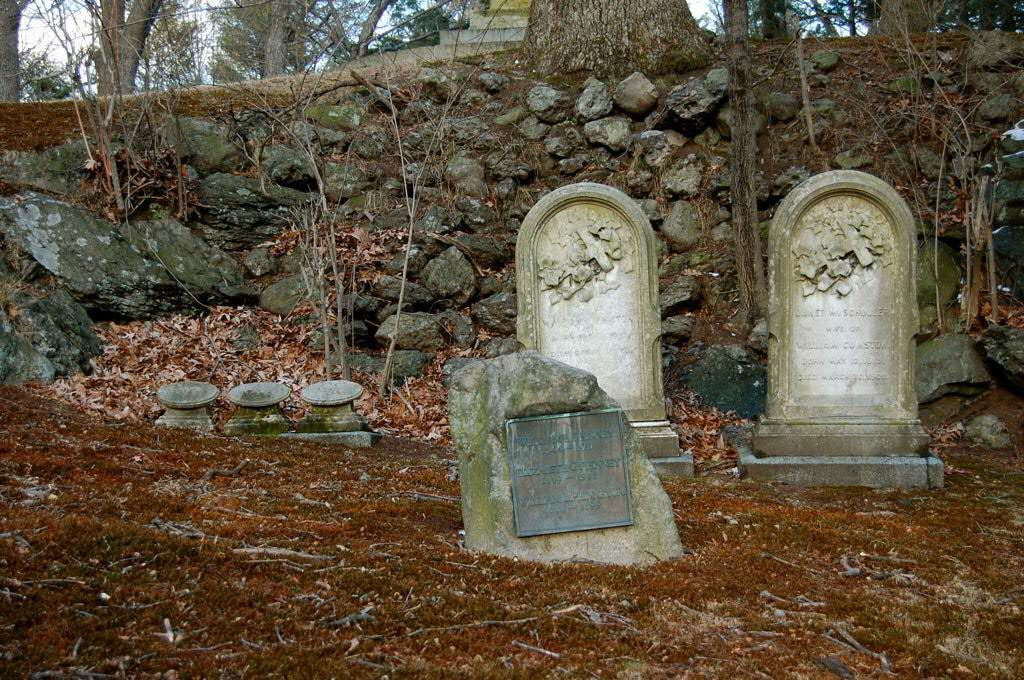What is the main subject of the image? The main subject of the image is graves in the center. What can be seen in the background of the image? In the background, there are stones, trees, stairs, and the sky. What is present at the bottom of the image? Dry leaves and the ground are present at the bottom of the image. What type of prison can be seen near the coast in the image? There is no prison or coast present in the image; it features graves, stones, trees, stairs, and the sky. How many army vehicles are visible in the image? There are no army vehicles present in the image. 